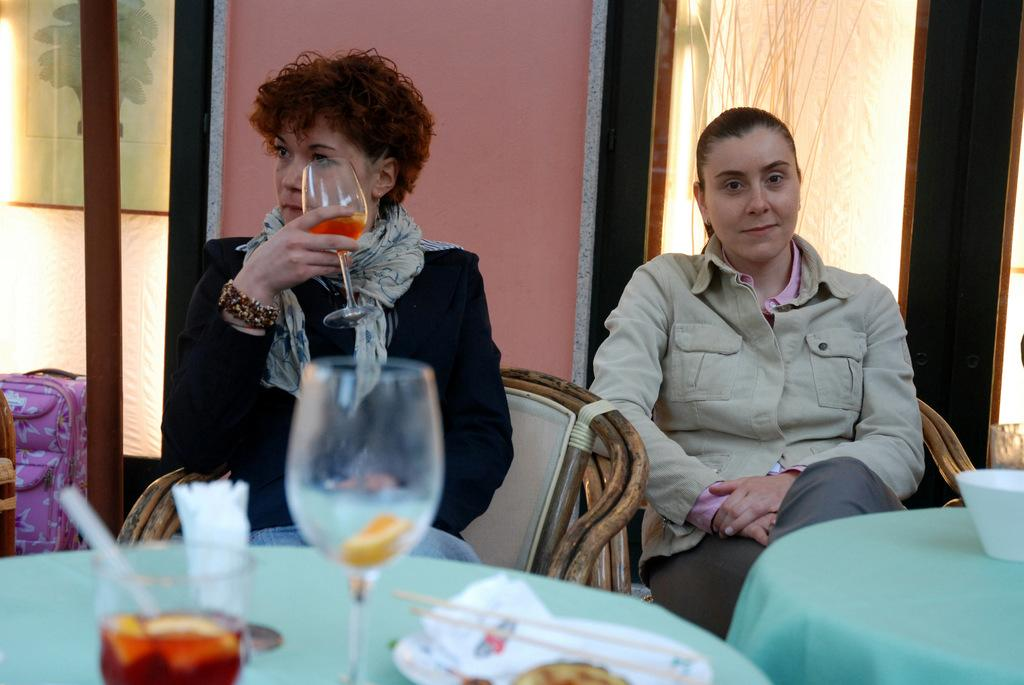How many women are in the image? There are two women in the image. What are the women doing in the image? The women are sitting on chairs. What is the woman on the left side holding? The woman on the left side is holding a glass of juice. What is present in front of the women? There is a table in front of the women. What can be found on the table? The table contains glasses and a bowl. How many fingers does the woman on the right side have on her left hand in the image? There is no information provided about the number of fingers on the woman's hand, and therefore it cannot be determined from the image. 